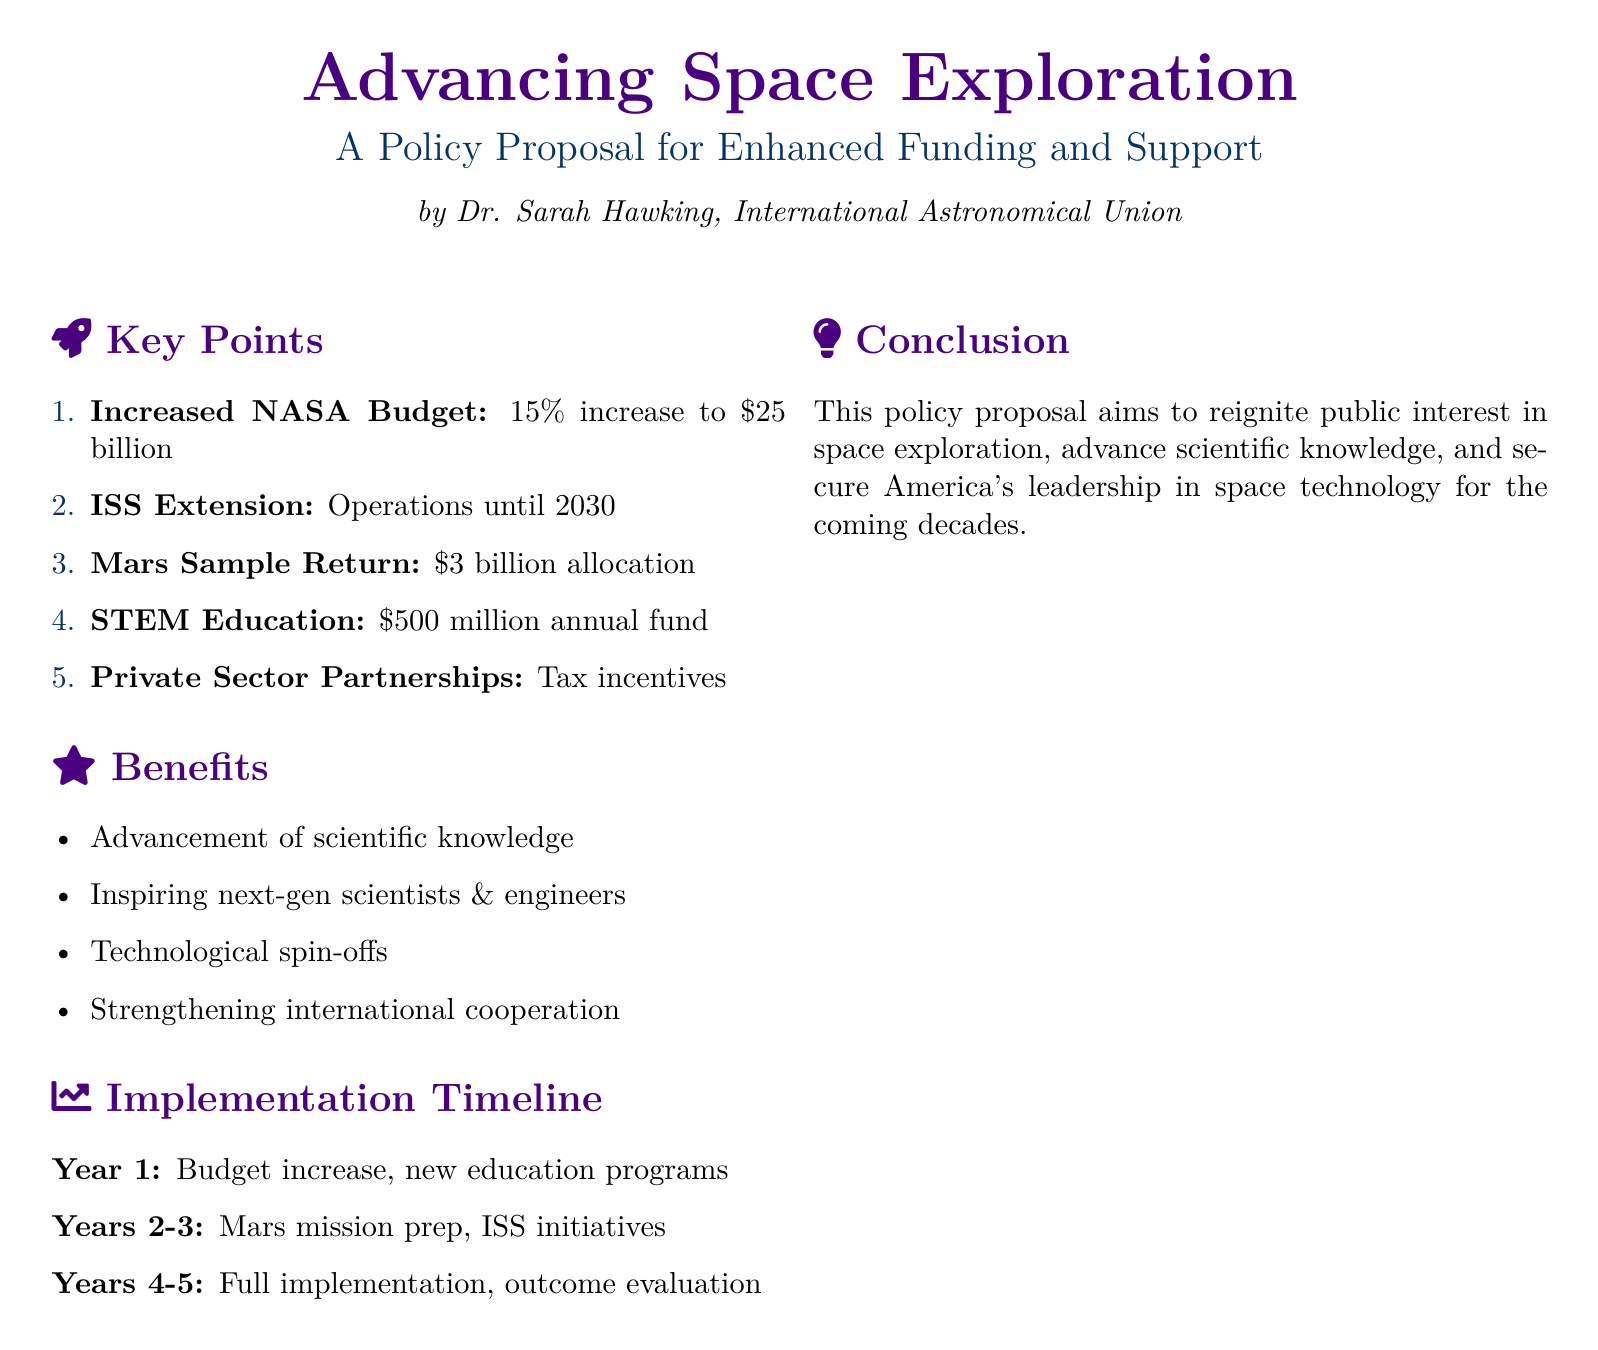What is the proposed increase to NASA's budget? The document states a proposed 15% increase to the NASA budget, raising it to $25 billion.
Answer: $25 billion What is the allocated budget for Mars Sample Return? The document specifically mentions a budget allocation of $3 billion for the Mars Sample Return initiative.
Answer: $3 billion How much annual funding is proposed for STEM education? According to the document, the proposed annual fund for STEM education is $500 million.
Answer: $500 million What year is the ISS operations extended until? The proposal extends ISS operations until the year 2030.
Answer: 2030 What is one of the key benefits of the proposed policy? The document highlights the advancement of scientific knowledge as one key benefit.
Answer: Advancement of scientific knowledge Which two areas are emphasized for partnerships? The proposal emphasizes partnerships with the private sector through tax incentives.
Answer: Private Sector Partnerships What is the timeline for Year 1 of the implementation? In Year 1, the timeline includes a budget increase and the introduction of new education programs.
Answer: Budget increase, new education programs What is the main goal of the policy proposal? The main goal is to reignite public interest in space exploration and advance scientific knowledge.
Answer: Reignite public interest in space exploration 